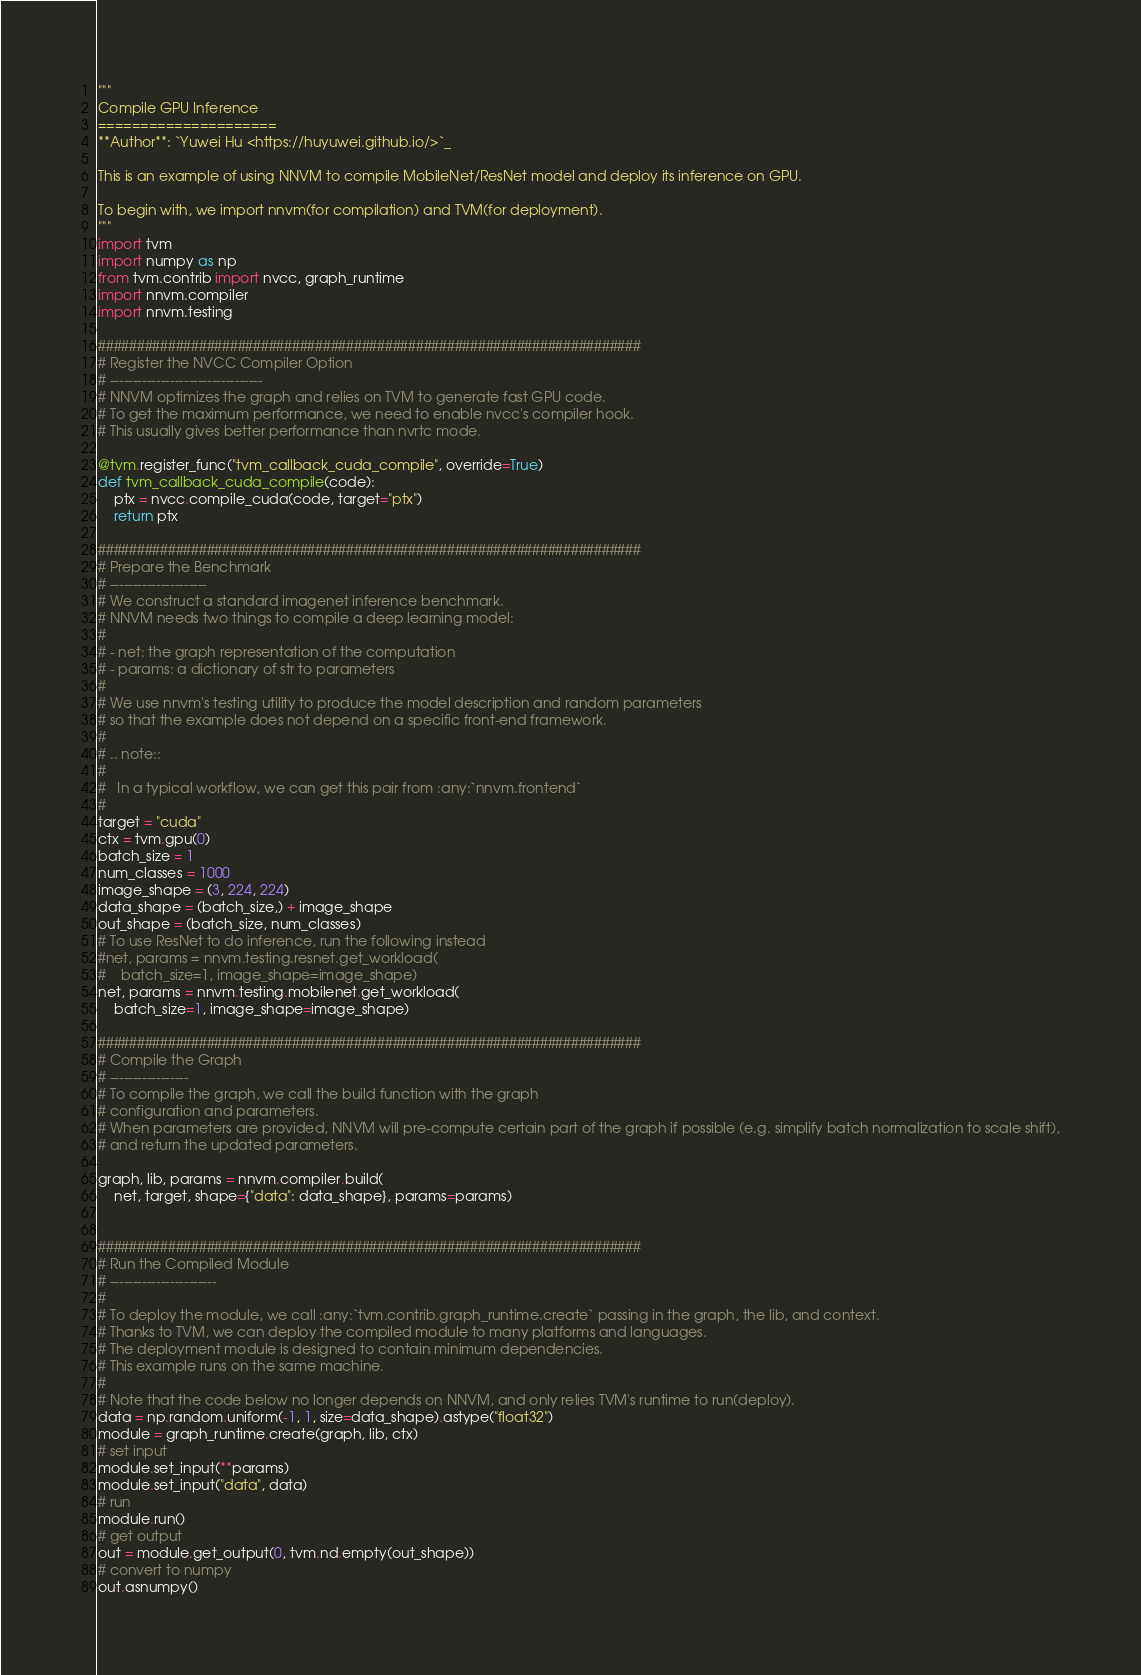Convert code to text. <code><loc_0><loc_0><loc_500><loc_500><_Python_>"""
Compile GPU Inference
=====================
**Author**: `Yuwei Hu <https://huyuwei.github.io/>`_

This is an example of using NNVM to compile MobileNet/ResNet model and deploy its inference on GPU.

To begin with, we import nnvm(for compilation) and TVM(for deployment).
"""
import tvm
import numpy as np
from tvm.contrib import nvcc, graph_runtime
import nnvm.compiler
import nnvm.testing

######################################################################
# Register the NVCC Compiler Option
# ---------------------------------
# NNVM optimizes the graph and relies on TVM to generate fast GPU code.
# To get the maximum performance, we need to enable nvcc's compiler hook.
# This usually gives better performance than nvrtc mode.

@tvm.register_func("tvm_callback_cuda_compile", override=True)
def tvm_callback_cuda_compile(code):
    ptx = nvcc.compile_cuda(code, target="ptx")
    return ptx

######################################################################
# Prepare the Benchmark
# ---------------------
# We construct a standard imagenet inference benchmark.
# NNVM needs two things to compile a deep learning model:
#
# - net: the graph representation of the computation
# - params: a dictionary of str to parameters
#
# We use nnvm's testing utility to produce the model description and random parameters
# so that the example does not depend on a specific front-end framework.
#
# .. note::
#
#   In a typical workflow, we can get this pair from :any:`nnvm.frontend`
#
target = "cuda"
ctx = tvm.gpu(0)
batch_size = 1
num_classes = 1000
image_shape = (3, 224, 224)
data_shape = (batch_size,) + image_shape
out_shape = (batch_size, num_classes)
# To use ResNet to do inference, run the following instead
#net, params = nnvm.testing.resnet.get_workload(
#    batch_size=1, image_shape=image_shape)
net, params = nnvm.testing.mobilenet.get_workload(
    batch_size=1, image_shape=image_shape)

######################################################################
# Compile the Graph
# -----------------
# To compile the graph, we call the build function with the graph
# configuration and parameters.
# When parameters are provided, NNVM will pre-compute certain part of the graph if possible (e.g. simplify batch normalization to scale shift),
# and return the updated parameters.

graph, lib, params = nnvm.compiler.build(
    net, target, shape={"data": data_shape}, params=params)


######################################################################
# Run the Compiled Module
# -----------------------
#
# To deploy the module, we call :any:`tvm.contrib.graph_runtime.create` passing in the graph, the lib, and context.
# Thanks to TVM, we can deploy the compiled module to many platforms and languages.
# The deployment module is designed to contain minimum dependencies.
# This example runs on the same machine.
#
# Note that the code below no longer depends on NNVM, and only relies TVM's runtime to run(deploy).
data = np.random.uniform(-1, 1, size=data_shape).astype("float32")
module = graph_runtime.create(graph, lib, ctx)
# set input
module.set_input(**params)
module.set_input("data", data)
# run
module.run()
# get output
out = module.get_output(0, tvm.nd.empty(out_shape))
# convert to numpy
out.asnumpy()
</code> 